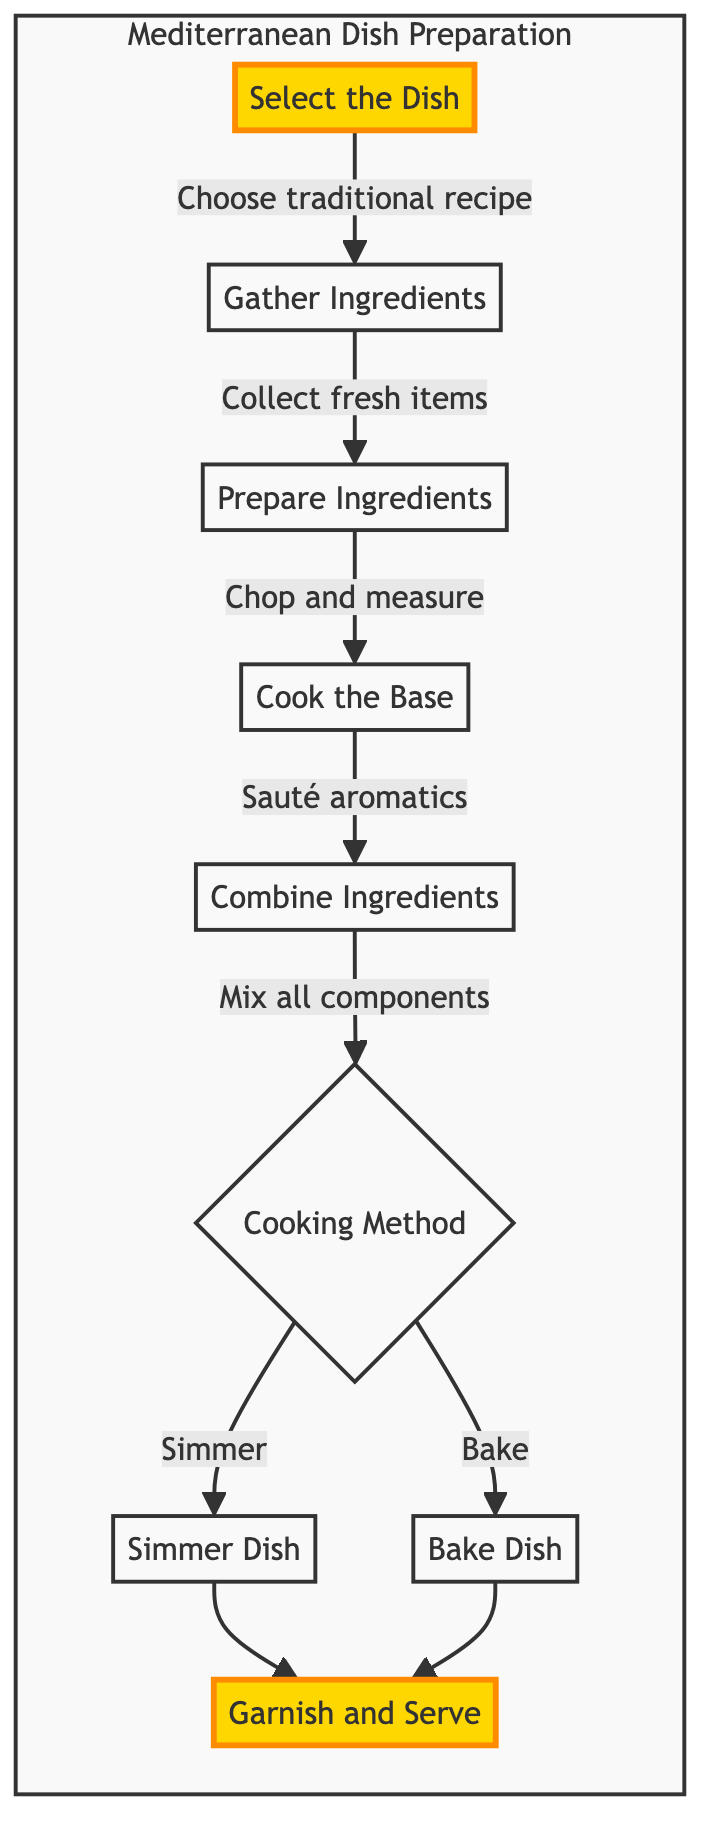What is the first step to prepare a traditional Mediterranean dish? The flowchart indicates that the first step is represented by node A, labeled "Select the Dish".
Answer: Select the Dish How many main cooking methods are depicted in the diagram? The diagram shows a decision point at node F, which leads to two outcomes: "Simmer" and "Bake". Therefore, there are 2 main cooking methods.
Answer: 2 What is combined in step E? In step E, labeled "Combine Ingredients", the elements that are mixed together include vegetables, proteins, and spices as indicated by the description.
Answer: Vegetables, proteins, and spices Which step involves sautéing aromatics? The process of sautéing aromatics is described in step D, which is labeled "Cook the Base".
Answer: Cook the Base What step comes after "Prepare Ingredients"? Following step C, "Prepare Ingredients", the next step in the flow is step D, "Cook the Base".
Answer: Cook the Base How many steps are there in total before serving the dish? By observing the flowchart, there are 7 steps leading up to "Garnish and Serve", ranging from "Select the Dish" to "Combine Ingredients", and the two cooking methods.
Answer: 7 What is the final action in the preparation process? The end action in the diagram is represented by node I, which is labeled "Garnish and Serve". This indicates that garnishing and serving the dish is the last step.
Answer: Garnish and Serve Which step includes the preparation of fresh items? The "Gather Ingredients" step, labeled as step B, is the one that includes the collection of fresh ingredients for cooking.
Answer: Gather Ingredients What happens if you opt for the "Bake" method? If you choose the "Bake" method, it directly leads from node F to node H, which is labeled "Bake Dish", and subsequently leads to serving.
Answer: Bake Dish 